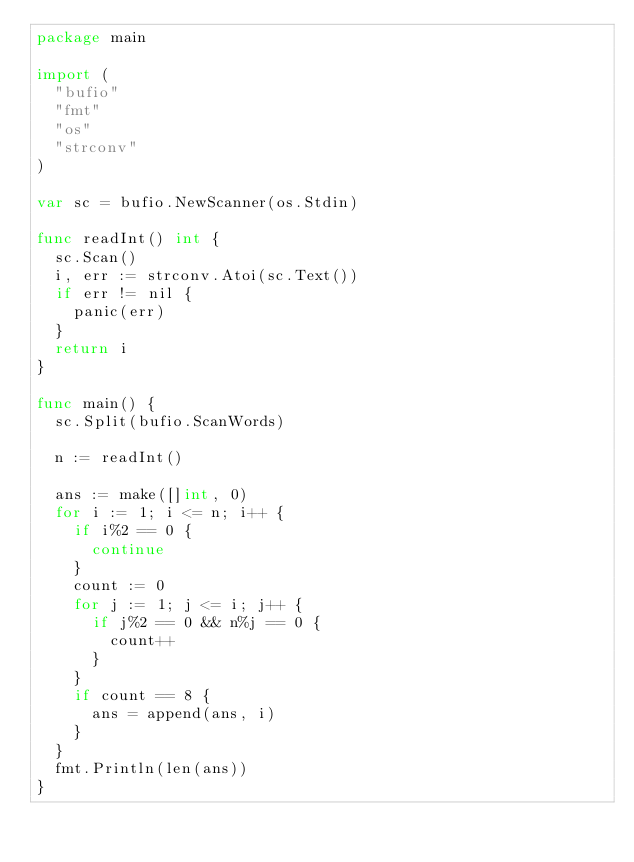<code> <loc_0><loc_0><loc_500><loc_500><_Go_>package main

import (
	"bufio"
	"fmt"
	"os"
	"strconv"
)

var sc = bufio.NewScanner(os.Stdin)

func readInt() int {
	sc.Scan()
	i, err := strconv.Atoi(sc.Text())
	if err != nil {
		panic(err)
	}
	return i
}

func main() {
	sc.Split(bufio.ScanWords)

	n := readInt()

	ans := make([]int, 0)
	for i := 1; i <= n; i++ {
		if i%2 == 0 {
			continue
		}
		count := 0
		for j := 1; j <= i; j++ {
			if j%2 == 0 && n%j == 0 {
				count++
			}
		}
		if count == 8 {
			ans = append(ans, i)
		}
	}
	fmt.Println(len(ans))
}
</code> 